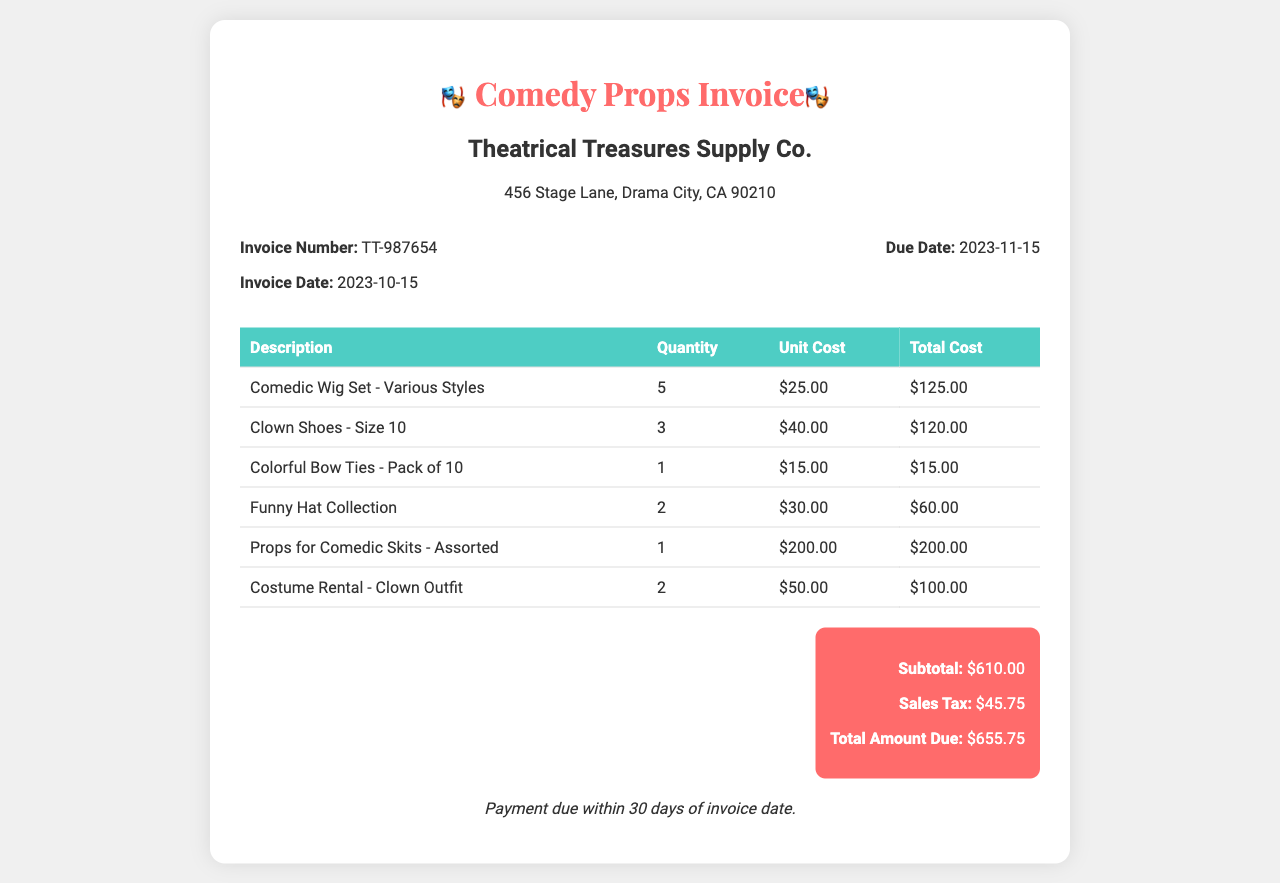What is the invoice number? The invoice number is provided in the details section of the document.
Answer: TT-987654 What is the due date for payment? The due date is mentioned under the invoice details section.
Answer: 2023-11-15 How many Clown Shoes were ordered? The quantity of Clown Shoes can be found in the table detailing the items.
Answer: 3 What is the total amount due? The total amount due is the sum of the subtotal and sales tax, provided at the bottom of the document.
Answer: $655.75 What is the sales tax amount? The sales tax amount is explicitly stated in the total section of the document.
Answer: $45.75 What is the total quantity of Comedic Wig Sets ordered? The total quantity is found in the itemized list of props and costumes.
Answer: 5 Which store issued the invoice? The name of the issuing store is located at the top section of the invoice.
Answer: Theatrical Treasures Supply Co What is the invoice date? The date of the invoice is listed alongside the invoice number in the details section.
Answer: 2023-10-15 What is the purpose of the invoice? The purpose is generally indicated in the title and by the items listed within.
Answer: Props and costumes for the next show 